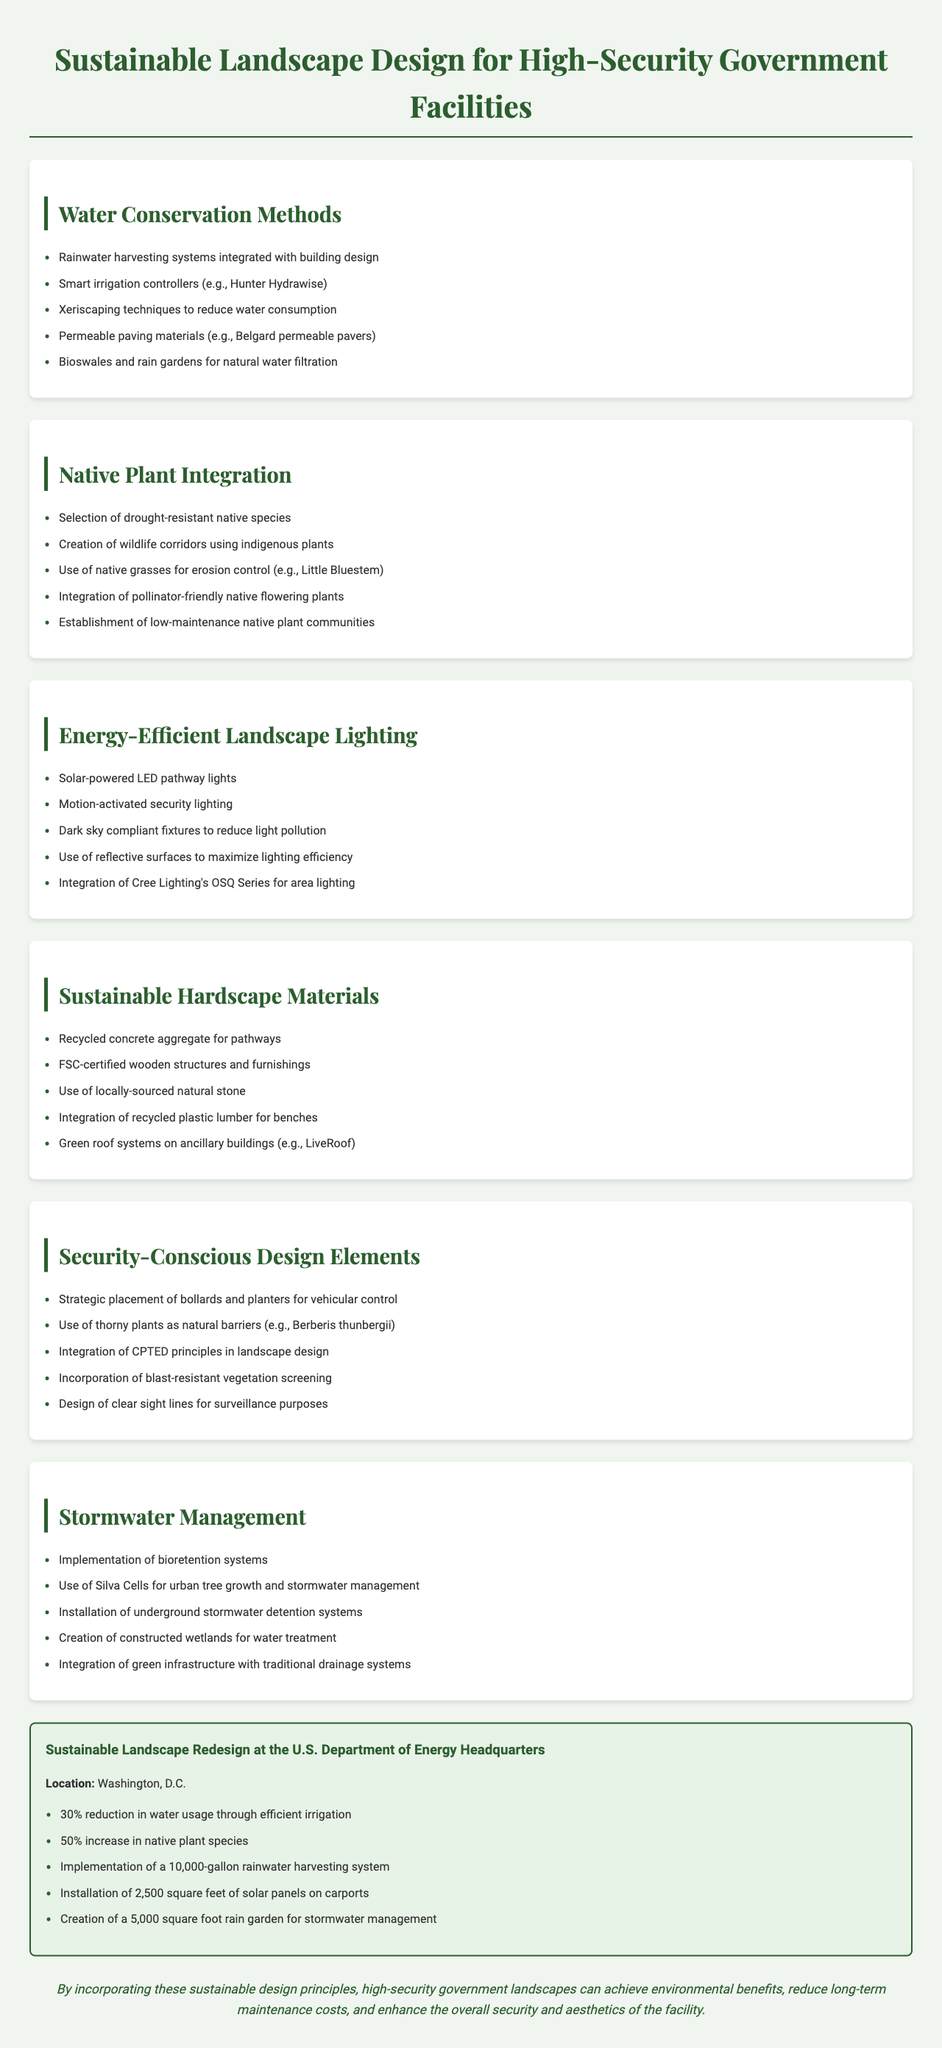What is the title of the brochure? The title is presented at the top of the document as the main heading.
Answer: Sustainable Landscape Design for High-Security Government Facilities How many key features are listed in the case study? The number of features can be found by counting the items in the key features list in the case study section.
Answer: 5 What is one method mentioned for stormwater management? The methods can be found under the Stormwater Management section; any listed method counts as an answer.
Answer: Bioretention systems Which native grass is mentioned for erosion control? The specific native grass used for erosion control is highlighted in the Native Plant Integration section.
Answer: Little Bluestem What type of lighting is suggested for energy efficiency? The document provides specific examples of lighting types under the Energy-Efficient Landscape Lighting section.
Answer: Solar-powered LED pathway lights What is a benefit of using native plants in design? The advantages are discussed in the Native Plant Integration section, often tied to environmental benefits.
Answer: Drought-resistant How much water usage reduction was achieved in the case study? The percentage reduction is mentioned in the key features of the case study.
Answer: 30% What type of systems are used for natural water filtration? The systems for natural water filtration can be found under the Water Conservation Methods section.
Answer: Bioswales and rain gardens What type of materials are recommended for hardscape? The Sustainable Hardscape Materials section lists the types of materials that should be considered.
Answer: Recycled concrete aggregate 